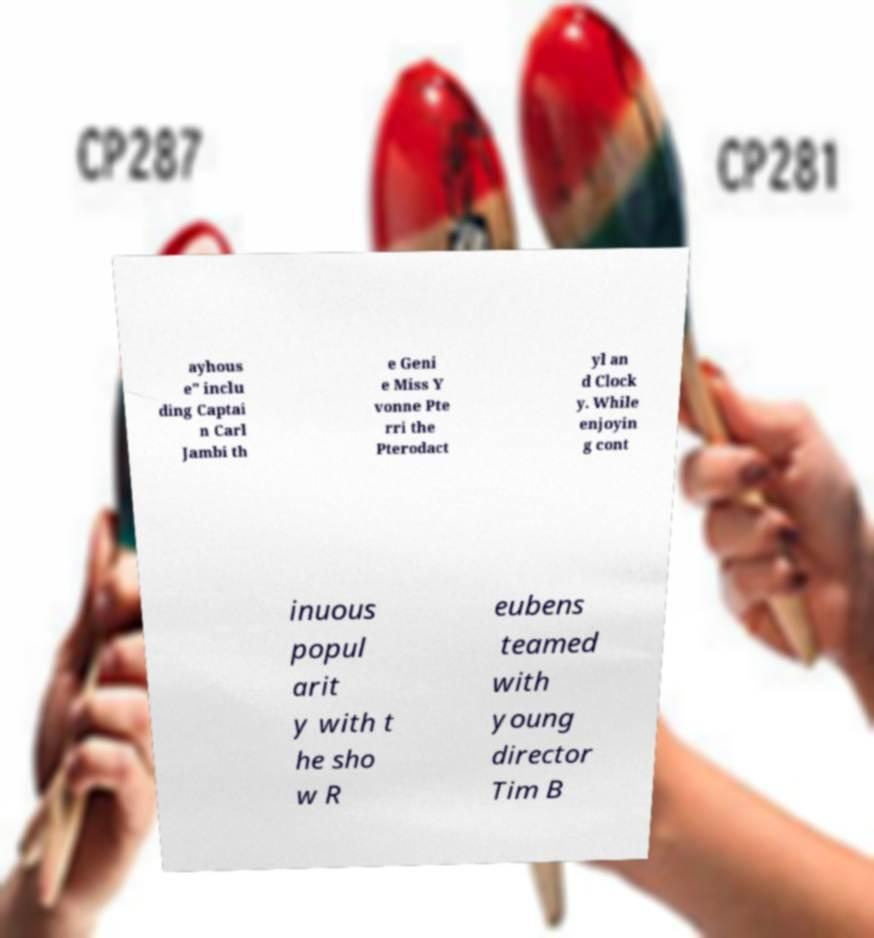Could you assist in decoding the text presented in this image and type it out clearly? ayhous e" inclu ding Captai n Carl Jambi th e Geni e Miss Y vonne Pte rri the Pterodact yl an d Clock y. While enjoyin g cont inuous popul arit y with t he sho w R eubens teamed with young director Tim B 